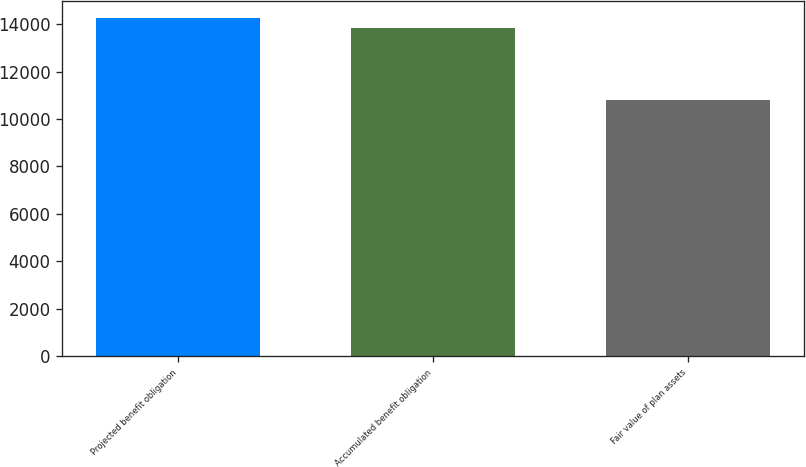Convert chart. <chart><loc_0><loc_0><loc_500><loc_500><bar_chart><fcel>Projected benefit obligation<fcel>Accumulated benefit obligation<fcel>Fair value of plan assets<nl><fcel>14247<fcel>13832<fcel>10786<nl></chart> 